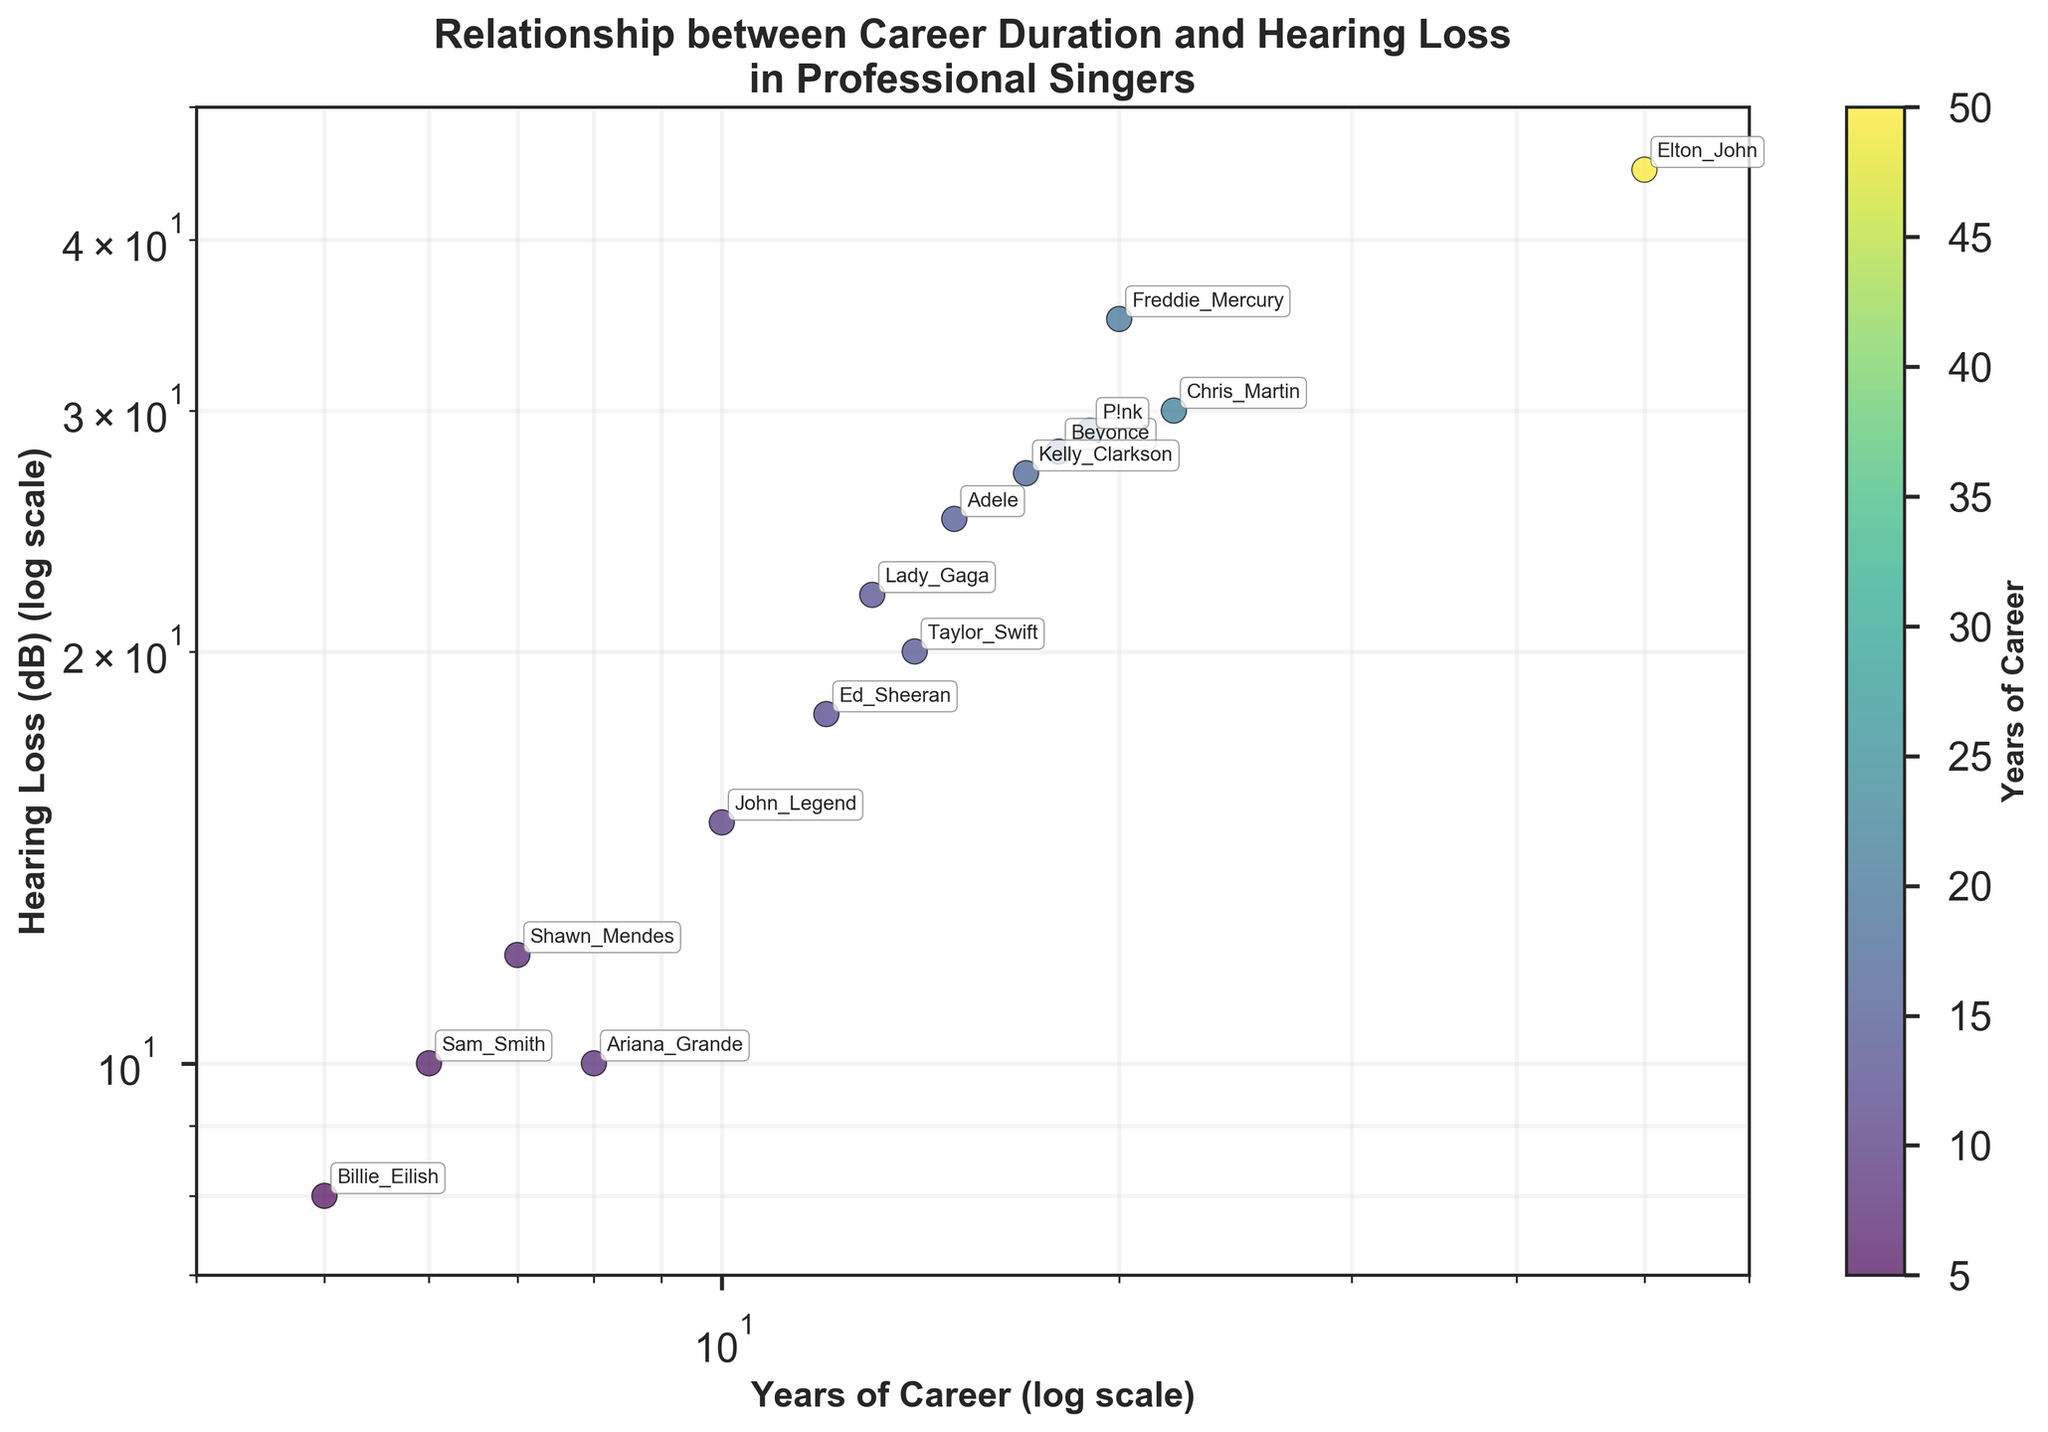What is the title of the figure? The title is displayed at the top of the figure. It summarizes what the scatter plot is depicting.
Answer: Relationship between Career Duration and Hearing Loss in Professional Singers How many singers are included in the scatter plot? The number of singers is depicted by the number of data points in the scatter plot. There is one data point for each singer.
Answer: 15 Which singer has the highest hearing loss and what is the value? Spot the point which represents the highest value on the y-axis (Hearing Loss in dB), and identify the corresponding singer from the annotation.
Answer: Elton John, 45 dB What is the hearing loss (in dB) for singers with a career length of around 10 years? Locate the points on the x-axis close to 10 years and read off their y-axis values. The singers should be John Legend and Ed Sheeran.
Answer: John Legend: 15 dB, Ed Sheeran: 18 dB Compare Beyoncé and Kelly Clarkson. Who has a longer career and who has more hearing loss? Locate both singers on the plot and compare their positions on the x-axis for career length and y-axis for hearing loss.
Answer: Beyoncé: Longer career, Kelly Clarkson: More hearing loss What trend do you observe between the duration of the singing career and hearing loss? Examine the general pattern of the data points in the scatter plot, considering if they trend upwards or downwards.
Answer: Longer careers tend to correlate with higher hearing loss Which range of career duration seems to have the highest variability in hearing loss? Look for the x-axis range where data points have the widest spread on the y-axis.
Answer: 15-22 years Who has a shorter career but higher hearing loss when comparing Shawn Mendes and Billie Eilish? Locate both singers on the plot and compare their x-axis (career length) and y-axis (hearing loss) values.
Answer: Shawn Mendes Are there any singers who have more than 20 years of career and less than 30 dB of hearing loss? If yes, who are they? Identify any points with an x-axis value greater than 20 years and a y-axis value less than 30 dB.
Answer: Chris Martin What can be said about the position of Adele in terms of career duration and hearing loss? Locate Adele's data point on the scatter plot to determine her position on both the x-axis (career duration) and y-axis (hearing loss).
Answer: Adele has 15 years of career and 25 dB of hearing loss 